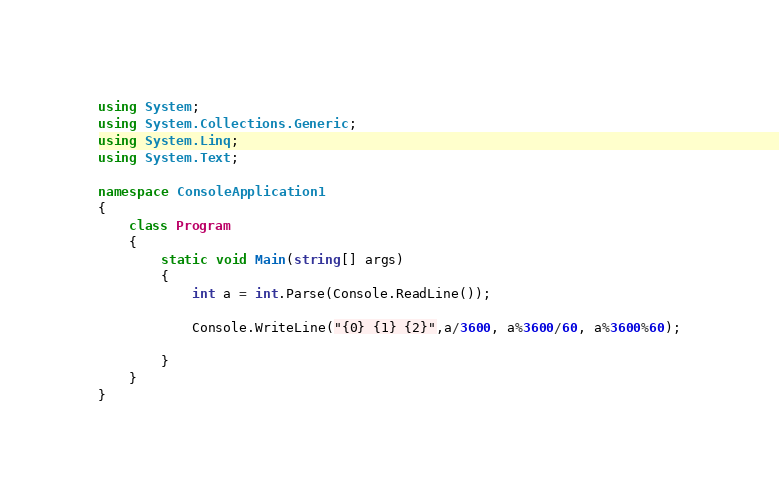Convert code to text. <code><loc_0><loc_0><loc_500><loc_500><_C#_>using System;
using System.Collections.Generic;
using System.Linq;
using System.Text;

namespace ConsoleApplication1
{
    class Program
    {
        static void Main(string[] args)
        {
            int a = int.Parse(Console.ReadLine());
            
            Console.WriteLine("{0} {1} {2}",a/3600, a%3600/60, a%3600%60);

        }
    }
}</code> 